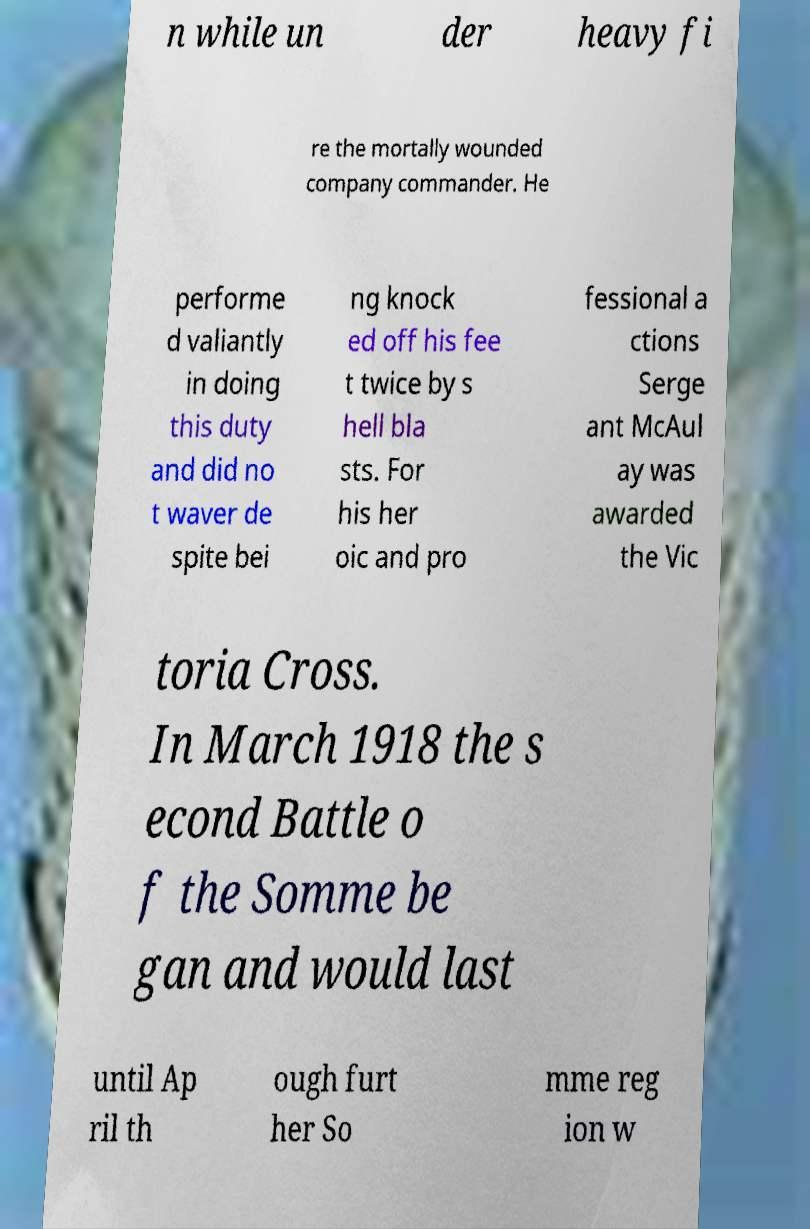Could you assist in decoding the text presented in this image and type it out clearly? n while un der heavy fi re the mortally wounded company commander. He performe d valiantly in doing this duty and did no t waver de spite bei ng knock ed off his fee t twice by s hell bla sts. For his her oic and pro fessional a ctions Serge ant McAul ay was awarded the Vic toria Cross. In March 1918 the s econd Battle o f the Somme be gan and would last until Ap ril th ough furt her So mme reg ion w 